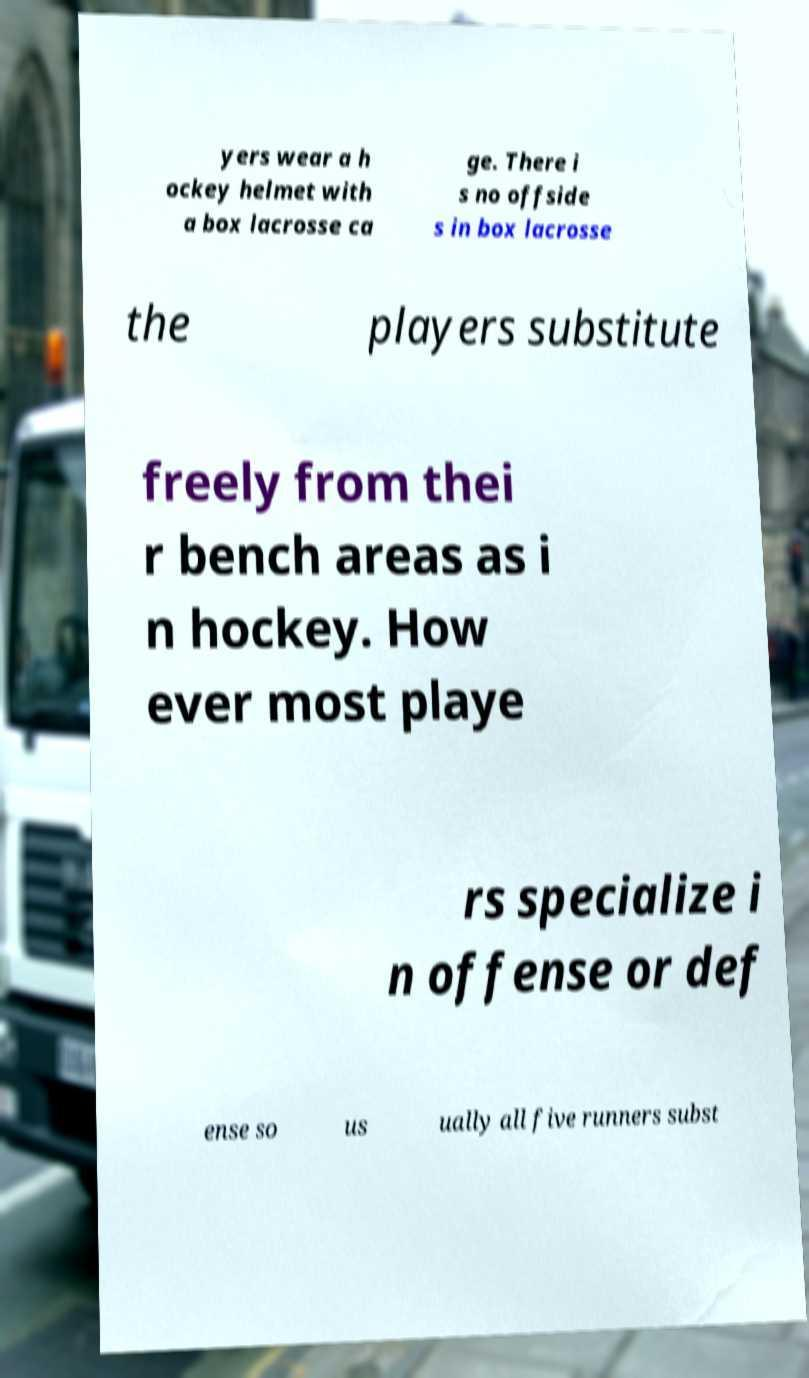There's text embedded in this image that I need extracted. Can you transcribe it verbatim? yers wear a h ockey helmet with a box lacrosse ca ge. There i s no offside s in box lacrosse the players substitute freely from thei r bench areas as i n hockey. How ever most playe rs specialize i n offense or def ense so us ually all five runners subst 